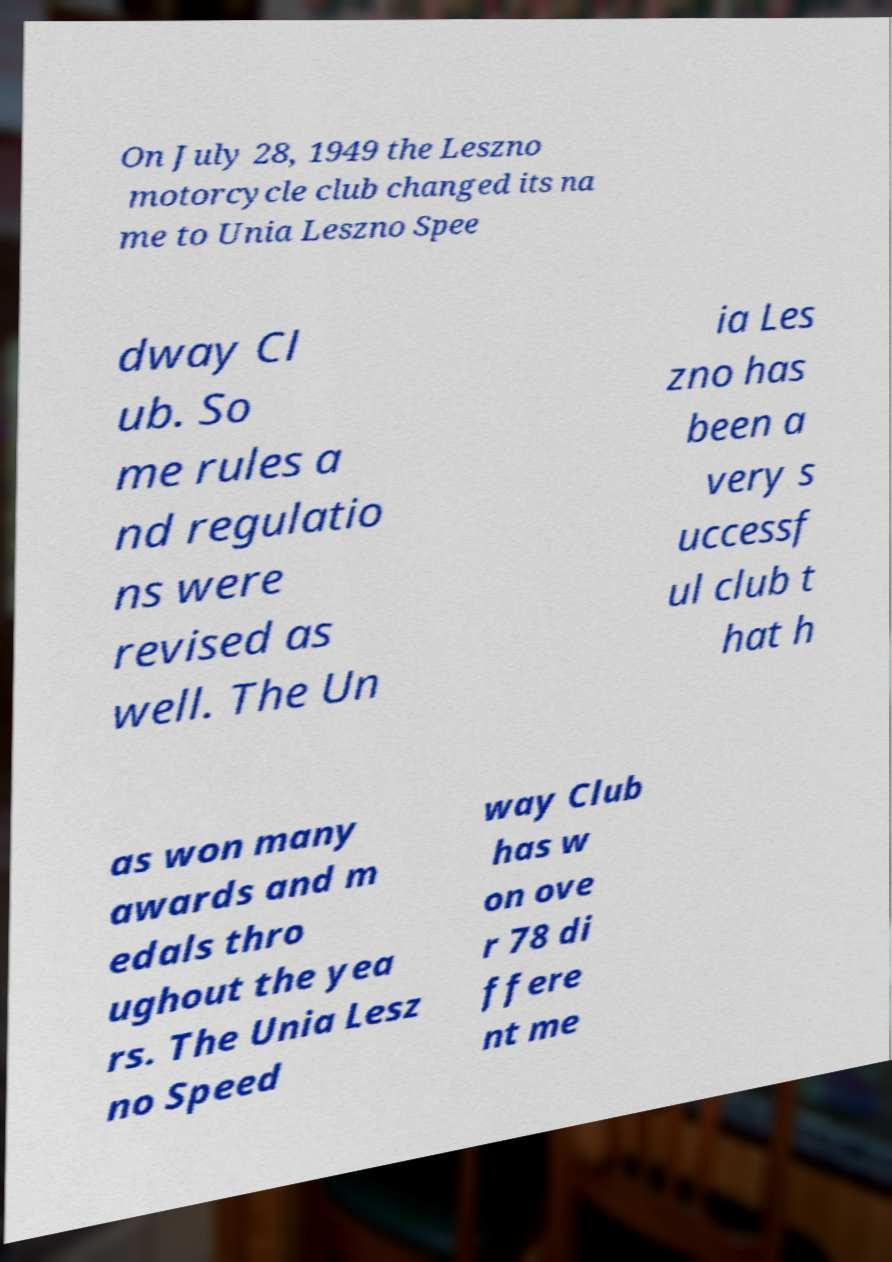I need the written content from this picture converted into text. Can you do that? On July 28, 1949 the Leszno motorcycle club changed its na me to Unia Leszno Spee dway Cl ub. So me rules a nd regulatio ns were revised as well. The Un ia Les zno has been a very s uccessf ul club t hat h as won many awards and m edals thro ughout the yea rs. The Unia Lesz no Speed way Club has w on ove r 78 di ffere nt me 